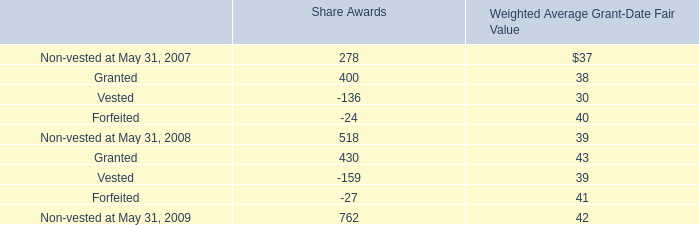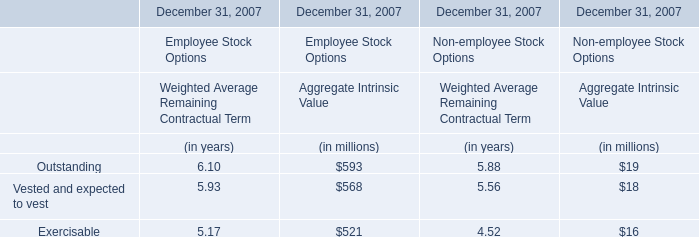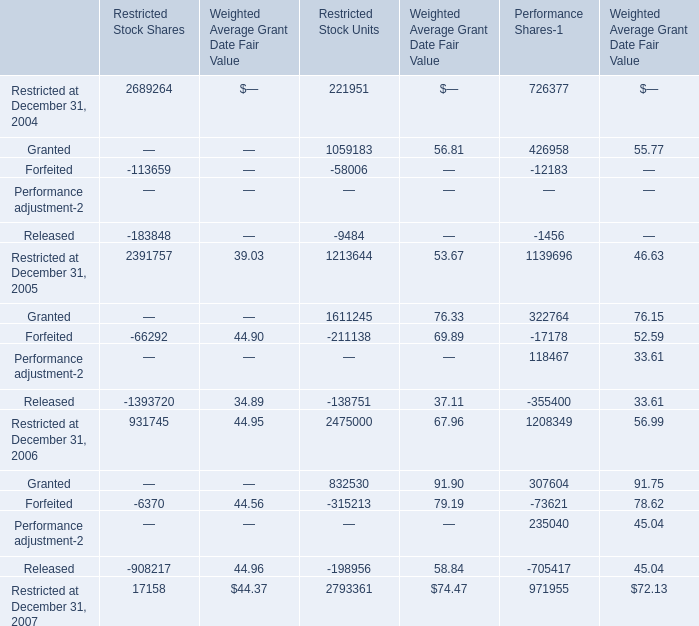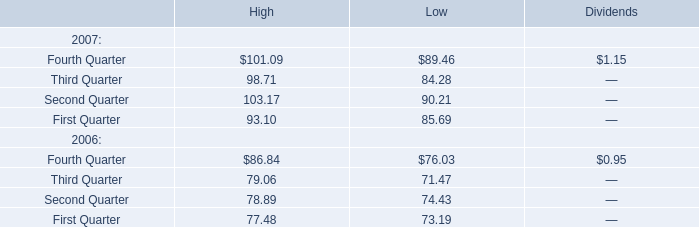What was the average of Restricted at December 31, 2005 for Restricted Stock Shares,Weighted Average Grant Date Fair Value and Restricted Stock Units? 
Computations: (((2391757 + 39.03) + 1213644) / 3)
Answer: 1201813.34333. 